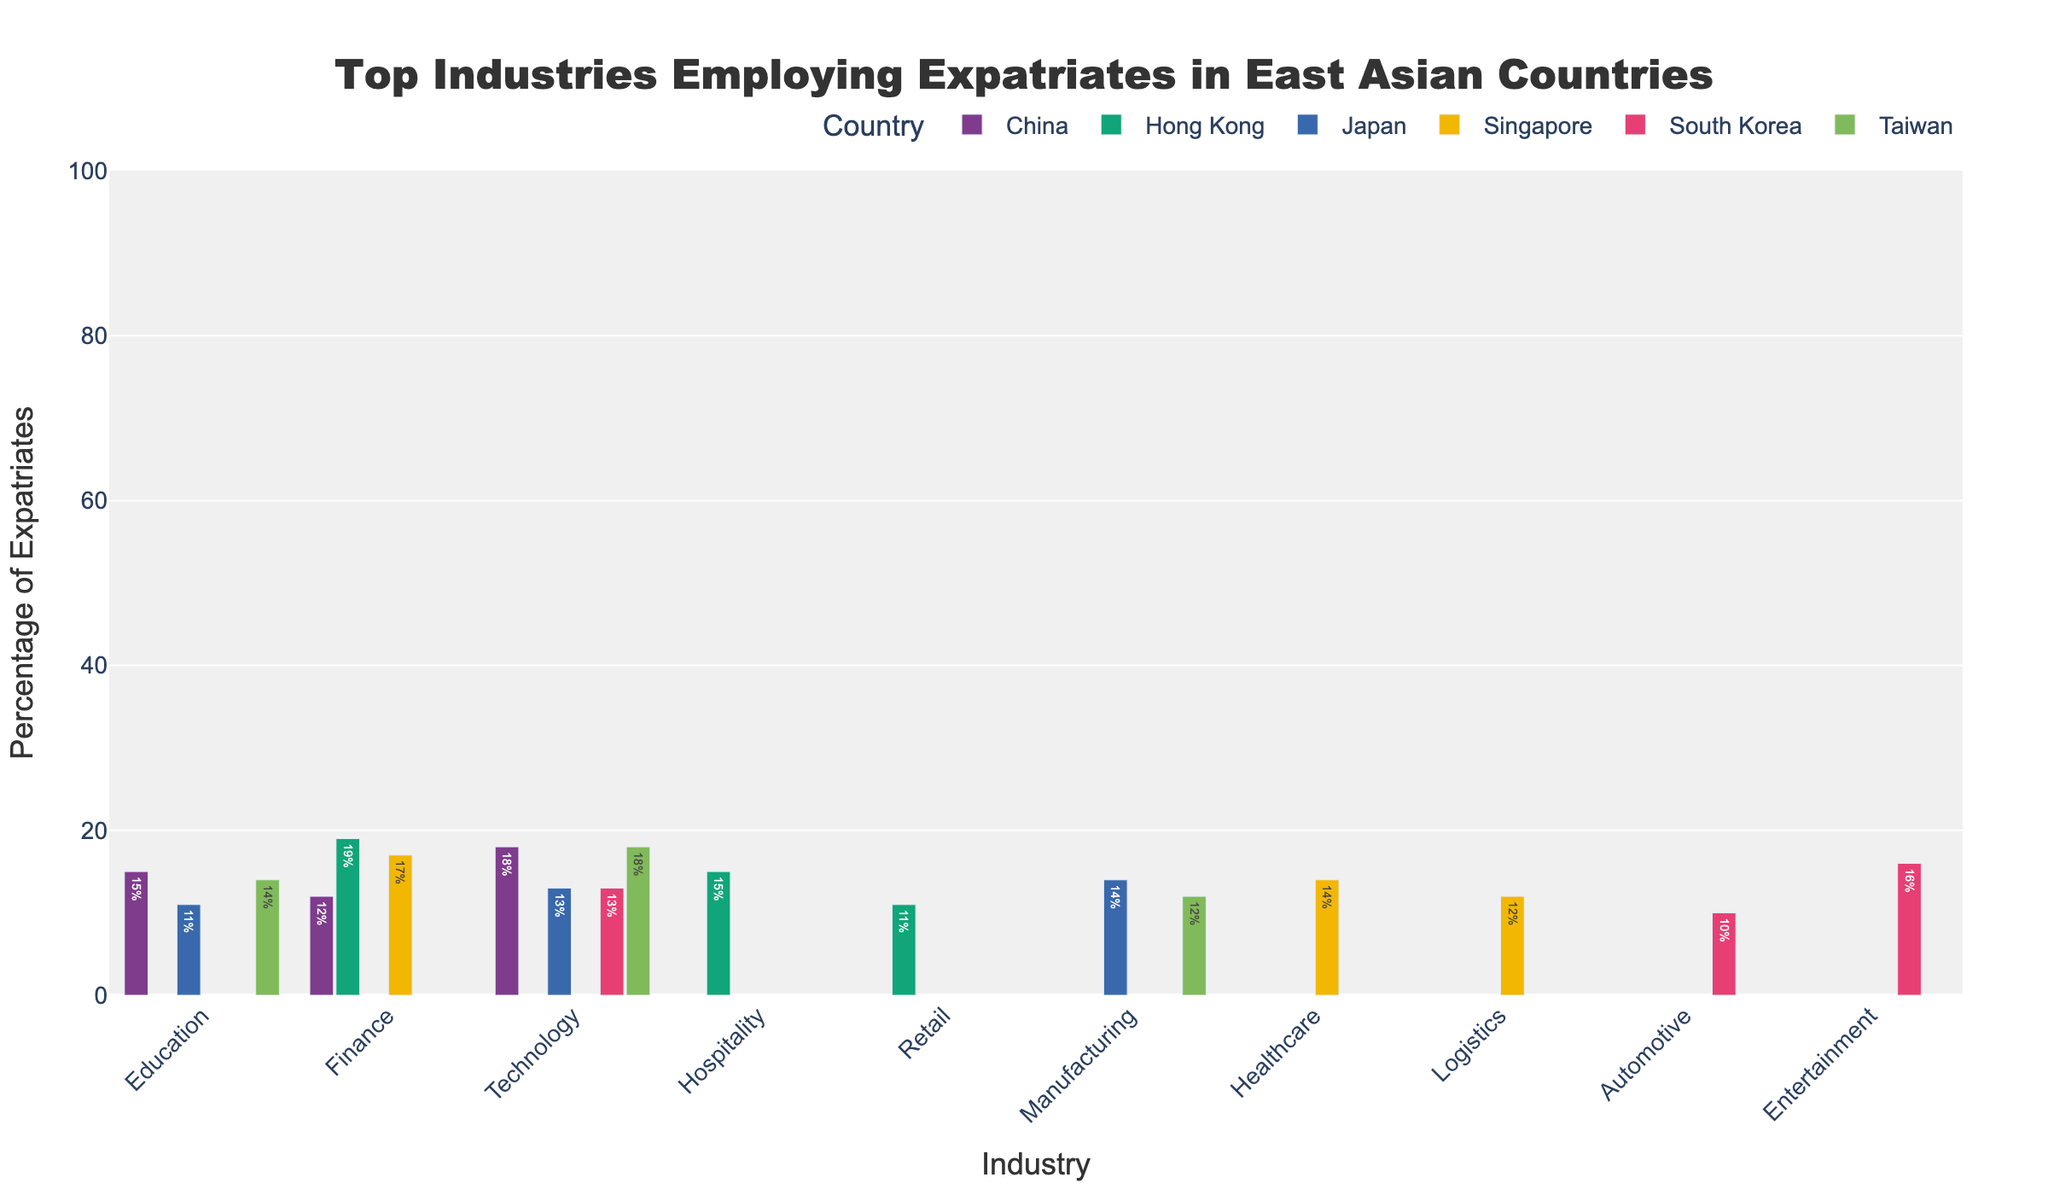What is the total percentage of expatriates employed across the Finance industry in all the countries? First, identify the individual percentages for the Finance industry in each country:
- China: 12%
- Singapore: 17%
- Hong Kong: 19%
Next, sum these percentages: 12 + 17 + 19 = 48.
Answer: 48% What is the average percentage of expatriates employed in the Education industry across all listed countries? Identify the percentages for the Education industry in each country:
- China: 15%
- Japan: 11%
- Taiwan: 14%
Sum these percentages: 15 + 11 + 14 = 40. Divide by the number of countries, which is 3: 40 / 3 ≈ 13.33.
Answer: 13.33% Which country has the highest percentage of expatriates in the Technology industry? Compare the percentages of the Technology industry for each country:
- China: 18%
- Japan: 13%
- South Korea: 13%
- Taiwan: 18%
Both China and Taiwan have the highest percentage of 18%.
Answer: China and Taiwan In South Korea, which industry employs more expatriates, Technology or Entertainment? Compare the percentages:
- Technology: 13%
- Entertainment: 16%
Entertainment employs more expatriates.
Answer: Entertainment Which country has the most distinct colors for its industries’ bars in the chart? By observing the bar colors in the chart for each country, identify the one with the most distinct colors among its industries.
Answer: (Answer depends on the actual colors used in the chart, but assume it is likely to be the country with the most different industries represented.) Which industry has taller bars in China, Technology or Finance? Compare the heights of the bars for Technology and Finance in China:
- Technology: 18%
- Finance: 12%
Technology has taller bars.
Answer: Technology What color are the bars representing the Finance industry in Hong Kong? By looking at the color of the Hong Kong bars for the Finance industry, identify the color.
Answer: (Answer depends on the actual color used in the chart.) Which industry has a lower bar percentage in Japan, Education or Manufacturing? Compare the heights of the bars for Education and Manufacturing:
- Education: 11%
- Manufacturing: 14%
Education has a lower percentage.
Answer: Education 